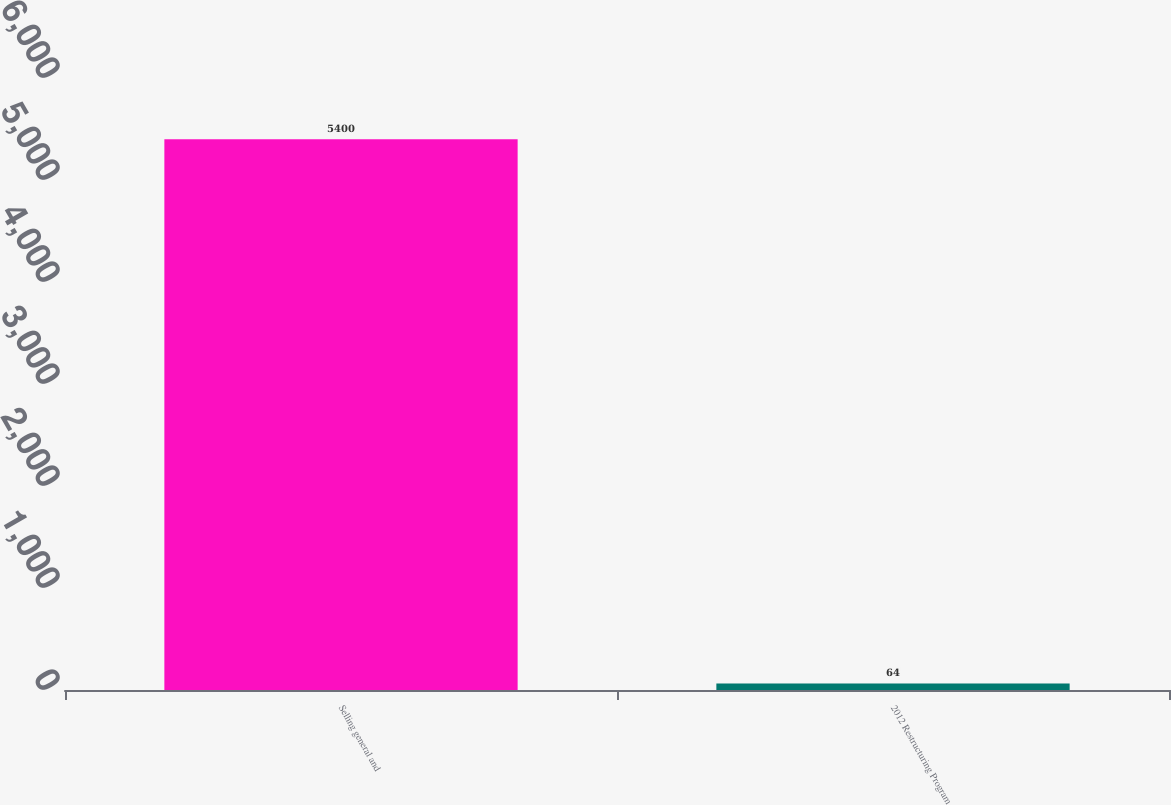<chart> <loc_0><loc_0><loc_500><loc_500><bar_chart><fcel>Selling general and<fcel>2012 Restructuring Program<nl><fcel>5400<fcel>64<nl></chart> 